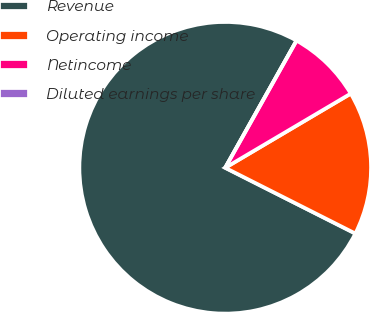<chart> <loc_0><loc_0><loc_500><loc_500><pie_chart><fcel>Revenue<fcel>Operating income<fcel>Netincome<fcel>Diluted earnings per share<nl><fcel>75.69%<fcel>15.94%<fcel>8.37%<fcel>0.0%<nl></chart> 